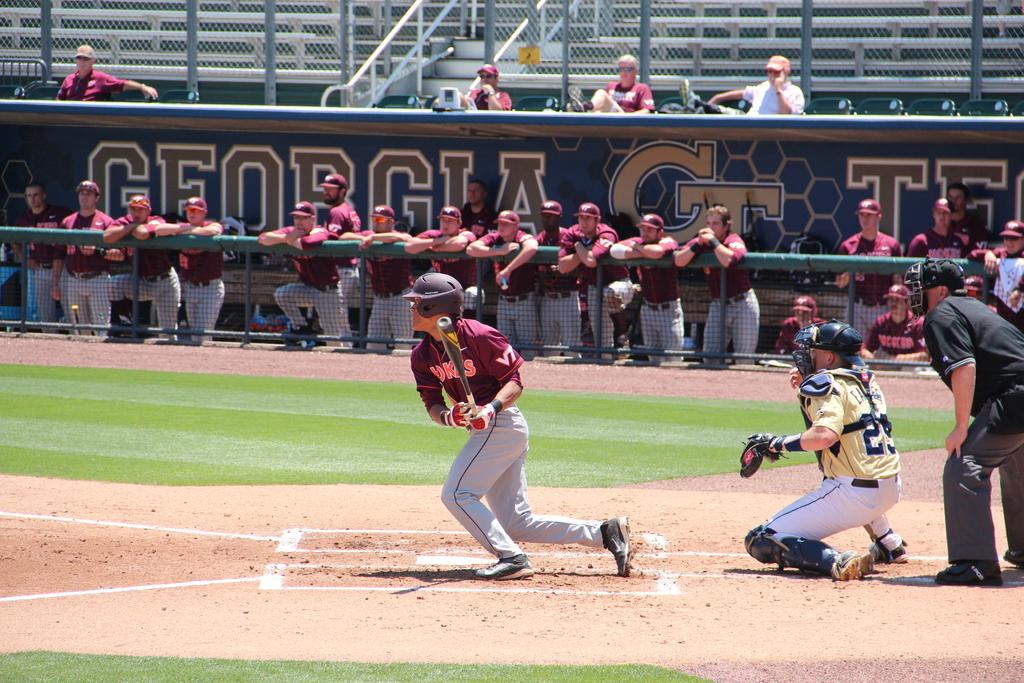What letters are on the sleeves of the red jerseys?
Your response must be concise. Vt. 